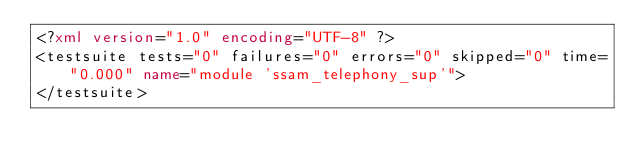<code> <loc_0><loc_0><loc_500><loc_500><_XML_><?xml version="1.0" encoding="UTF-8" ?>
<testsuite tests="0" failures="0" errors="0" skipped="0" time="0.000" name="module 'ssam_telephony_sup'">
</testsuite>
</code> 